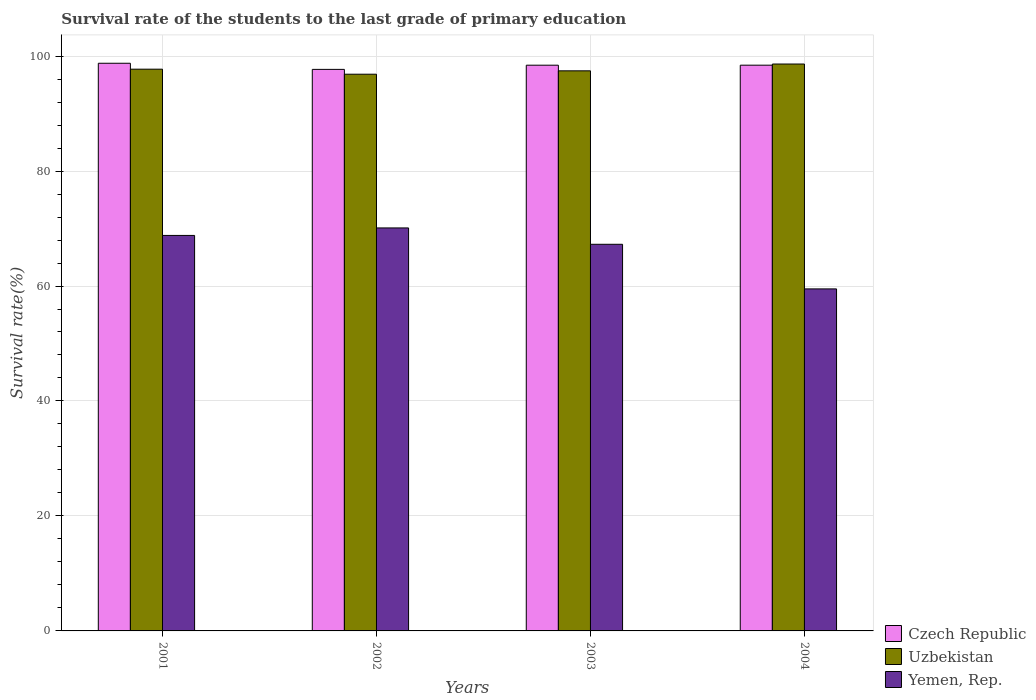Are the number of bars on each tick of the X-axis equal?
Give a very brief answer. Yes. How many bars are there on the 2nd tick from the left?
Ensure brevity in your answer.  3. What is the label of the 1st group of bars from the left?
Ensure brevity in your answer.  2001. In how many cases, is the number of bars for a given year not equal to the number of legend labels?
Provide a short and direct response. 0. What is the survival rate of the students in Yemen, Rep. in 2001?
Provide a succinct answer. 68.8. Across all years, what is the maximum survival rate of the students in Czech Republic?
Give a very brief answer. 98.75. Across all years, what is the minimum survival rate of the students in Uzbekistan?
Your answer should be compact. 96.84. In which year was the survival rate of the students in Yemen, Rep. maximum?
Give a very brief answer. 2002. In which year was the survival rate of the students in Uzbekistan minimum?
Offer a very short reply. 2002. What is the total survival rate of the students in Uzbekistan in the graph?
Offer a very short reply. 390.61. What is the difference between the survival rate of the students in Czech Republic in 2002 and that in 2004?
Make the answer very short. -0.73. What is the difference between the survival rate of the students in Czech Republic in 2003 and the survival rate of the students in Uzbekistan in 2001?
Your response must be concise. 0.69. What is the average survival rate of the students in Yemen, Rep. per year?
Provide a succinct answer. 66.41. In the year 2002, what is the difference between the survival rate of the students in Uzbekistan and survival rate of the students in Czech Republic?
Offer a very short reply. -0.84. What is the ratio of the survival rate of the students in Yemen, Rep. in 2001 to that in 2003?
Your answer should be very brief. 1.02. Is the difference between the survival rate of the students in Uzbekistan in 2001 and 2004 greater than the difference between the survival rate of the students in Czech Republic in 2001 and 2004?
Ensure brevity in your answer.  No. What is the difference between the highest and the second highest survival rate of the students in Yemen, Rep.?
Provide a short and direct response. 1.31. What is the difference between the highest and the lowest survival rate of the students in Uzbekistan?
Your answer should be very brief. 1.77. Is the sum of the survival rate of the students in Uzbekistan in 2001 and 2004 greater than the maximum survival rate of the students in Yemen, Rep. across all years?
Your answer should be compact. Yes. What does the 1st bar from the left in 2004 represents?
Provide a short and direct response. Czech Republic. What does the 1st bar from the right in 2001 represents?
Your response must be concise. Yemen, Rep. Is it the case that in every year, the sum of the survival rate of the students in Yemen, Rep. and survival rate of the students in Uzbekistan is greater than the survival rate of the students in Czech Republic?
Keep it short and to the point. Yes. How many bars are there?
Your response must be concise. 12. How many years are there in the graph?
Your answer should be compact. 4. What is the difference between two consecutive major ticks on the Y-axis?
Ensure brevity in your answer.  20. Are the values on the major ticks of Y-axis written in scientific E-notation?
Provide a succinct answer. No. Does the graph contain grids?
Give a very brief answer. Yes. Where does the legend appear in the graph?
Your response must be concise. Bottom right. How many legend labels are there?
Ensure brevity in your answer.  3. What is the title of the graph?
Ensure brevity in your answer.  Survival rate of the students to the last grade of primary education. What is the label or title of the X-axis?
Provide a short and direct response. Years. What is the label or title of the Y-axis?
Your answer should be very brief. Survival rate(%). What is the Survival rate(%) in Czech Republic in 2001?
Your answer should be very brief. 98.75. What is the Survival rate(%) in Uzbekistan in 2001?
Your response must be concise. 97.72. What is the Survival rate(%) in Yemen, Rep. in 2001?
Your response must be concise. 68.8. What is the Survival rate(%) in Czech Republic in 2002?
Give a very brief answer. 97.68. What is the Survival rate(%) in Uzbekistan in 2002?
Ensure brevity in your answer.  96.84. What is the Survival rate(%) in Yemen, Rep. in 2002?
Your answer should be very brief. 70.1. What is the Survival rate(%) in Czech Republic in 2003?
Give a very brief answer. 98.41. What is the Survival rate(%) in Uzbekistan in 2003?
Provide a short and direct response. 97.43. What is the Survival rate(%) in Yemen, Rep. in 2003?
Your answer should be compact. 67.26. What is the Survival rate(%) in Czech Republic in 2004?
Provide a succinct answer. 98.42. What is the Survival rate(%) in Uzbekistan in 2004?
Ensure brevity in your answer.  98.62. What is the Survival rate(%) of Yemen, Rep. in 2004?
Your answer should be compact. 59.5. Across all years, what is the maximum Survival rate(%) in Czech Republic?
Give a very brief answer. 98.75. Across all years, what is the maximum Survival rate(%) of Uzbekistan?
Keep it short and to the point. 98.62. Across all years, what is the maximum Survival rate(%) of Yemen, Rep.?
Offer a very short reply. 70.1. Across all years, what is the minimum Survival rate(%) of Czech Republic?
Give a very brief answer. 97.68. Across all years, what is the minimum Survival rate(%) in Uzbekistan?
Provide a succinct answer. 96.84. Across all years, what is the minimum Survival rate(%) of Yemen, Rep.?
Offer a very short reply. 59.5. What is the total Survival rate(%) of Czech Republic in the graph?
Provide a short and direct response. 393.26. What is the total Survival rate(%) in Uzbekistan in the graph?
Make the answer very short. 390.61. What is the total Survival rate(%) in Yemen, Rep. in the graph?
Give a very brief answer. 265.65. What is the difference between the Survival rate(%) in Czech Republic in 2001 and that in 2002?
Your response must be concise. 1.06. What is the difference between the Survival rate(%) in Uzbekistan in 2001 and that in 2002?
Ensure brevity in your answer.  0.88. What is the difference between the Survival rate(%) in Yemen, Rep. in 2001 and that in 2002?
Ensure brevity in your answer.  -1.31. What is the difference between the Survival rate(%) in Czech Republic in 2001 and that in 2003?
Give a very brief answer. 0.34. What is the difference between the Survival rate(%) in Uzbekistan in 2001 and that in 2003?
Provide a succinct answer. 0.29. What is the difference between the Survival rate(%) in Yemen, Rep. in 2001 and that in 2003?
Offer a very short reply. 1.54. What is the difference between the Survival rate(%) of Czech Republic in 2001 and that in 2004?
Offer a terse response. 0.33. What is the difference between the Survival rate(%) of Uzbekistan in 2001 and that in 2004?
Offer a terse response. -0.9. What is the difference between the Survival rate(%) of Yemen, Rep. in 2001 and that in 2004?
Provide a short and direct response. 9.3. What is the difference between the Survival rate(%) in Czech Republic in 2002 and that in 2003?
Your answer should be very brief. -0.73. What is the difference between the Survival rate(%) of Uzbekistan in 2002 and that in 2003?
Your response must be concise. -0.59. What is the difference between the Survival rate(%) of Yemen, Rep. in 2002 and that in 2003?
Offer a very short reply. 2.85. What is the difference between the Survival rate(%) in Czech Republic in 2002 and that in 2004?
Your answer should be very brief. -0.73. What is the difference between the Survival rate(%) of Uzbekistan in 2002 and that in 2004?
Your response must be concise. -1.77. What is the difference between the Survival rate(%) of Yemen, Rep. in 2002 and that in 2004?
Your answer should be very brief. 10.61. What is the difference between the Survival rate(%) in Czech Republic in 2003 and that in 2004?
Ensure brevity in your answer.  -0. What is the difference between the Survival rate(%) in Uzbekistan in 2003 and that in 2004?
Your answer should be very brief. -1.18. What is the difference between the Survival rate(%) in Yemen, Rep. in 2003 and that in 2004?
Offer a terse response. 7.76. What is the difference between the Survival rate(%) of Czech Republic in 2001 and the Survival rate(%) of Uzbekistan in 2002?
Offer a terse response. 1.91. What is the difference between the Survival rate(%) of Czech Republic in 2001 and the Survival rate(%) of Yemen, Rep. in 2002?
Offer a very short reply. 28.65. What is the difference between the Survival rate(%) in Uzbekistan in 2001 and the Survival rate(%) in Yemen, Rep. in 2002?
Your answer should be compact. 27.62. What is the difference between the Survival rate(%) in Czech Republic in 2001 and the Survival rate(%) in Uzbekistan in 2003?
Keep it short and to the point. 1.32. What is the difference between the Survival rate(%) of Czech Republic in 2001 and the Survival rate(%) of Yemen, Rep. in 2003?
Provide a succinct answer. 31.49. What is the difference between the Survival rate(%) of Uzbekistan in 2001 and the Survival rate(%) of Yemen, Rep. in 2003?
Your answer should be very brief. 30.46. What is the difference between the Survival rate(%) of Czech Republic in 2001 and the Survival rate(%) of Uzbekistan in 2004?
Your answer should be very brief. 0.13. What is the difference between the Survival rate(%) in Czech Republic in 2001 and the Survival rate(%) in Yemen, Rep. in 2004?
Offer a very short reply. 39.25. What is the difference between the Survival rate(%) of Uzbekistan in 2001 and the Survival rate(%) of Yemen, Rep. in 2004?
Offer a very short reply. 38.22. What is the difference between the Survival rate(%) of Czech Republic in 2002 and the Survival rate(%) of Uzbekistan in 2003?
Provide a succinct answer. 0.25. What is the difference between the Survival rate(%) in Czech Republic in 2002 and the Survival rate(%) in Yemen, Rep. in 2003?
Give a very brief answer. 30.43. What is the difference between the Survival rate(%) of Uzbekistan in 2002 and the Survival rate(%) of Yemen, Rep. in 2003?
Your response must be concise. 29.59. What is the difference between the Survival rate(%) in Czech Republic in 2002 and the Survival rate(%) in Uzbekistan in 2004?
Ensure brevity in your answer.  -0.93. What is the difference between the Survival rate(%) of Czech Republic in 2002 and the Survival rate(%) of Yemen, Rep. in 2004?
Keep it short and to the point. 38.19. What is the difference between the Survival rate(%) in Uzbekistan in 2002 and the Survival rate(%) in Yemen, Rep. in 2004?
Your answer should be very brief. 37.35. What is the difference between the Survival rate(%) of Czech Republic in 2003 and the Survival rate(%) of Uzbekistan in 2004?
Provide a succinct answer. -0.2. What is the difference between the Survival rate(%) of Czech Republic in 2003 and the Survival rate(%) of Yemen, Rep. in 2004?
Ensure brevity in your answer.  38.91. What is the difference between the Survival rate(%) of Uzbekistan in 2003 and the Survival rate(%) of Yemen, Rep. in 2004?
Your response must be concise. 37.93. What is the average Survival rate(%) in Czech Republic per year?
Your answer should be compact. 98.32. What is the average Survival rate(%) of Uzbekistan per year?
Give a very brief answer. 97.65. What is the average Survival rate(%) in Yemen, Rep. per year?
Give a very brief answer. 66.41. In the year 2001, what is the difference between the Survival rate(%) of Czech Republic and Survival rate(%) of Uzbekistan?
Provide a succinct answer. 1.03. In the year 2001, what is the difference between the Survival rate(%) in Czech Republic and Survival rate(%) in Yemen, Rep.?
Provide a succinct answer. 29.95. In the year 2001, what is the difference between the Survival rate(%) of Uzbekistan and Survival rate(%) of Yemen, Rep.?
Ensure brevity in your answer.  28.92. In the year 2002, what is the difference between the Survival rate(%) in Czech Republic and Survival rate(%) in Uzbekistan?
Provide a short and direct response. 0.84. In the year 2002, what is the difference between the Survival rate(%) of Czech Republic and Survival rate(%) of Yemen, Rep.?
Give a very brief answer. 27.58. In the year 2002, what is the difference between the Survival rate(%) in Uzbekistan and Survival rate(%) in Yemen, Rep.?
Provide a short and direct response. 26.74. In the year 2003, what is the difference between the Survival rate(%) of Czech Republic and Survival rate(%) of Uzbekistan?
Provide a short and direct response. 0.98. In the year 2003, what is the difference between the Survival rate(%) of Czech Republic and Survival rate(%) of Yemen, Rep.?
Provide a short and direct response. 31.16. In the year 2003, what is the difference between the Survival rate(%) of Uzbekistan and Survival rate(%) of Yemen, Rep.?
Offer a very short reply. 30.18. In the year 2004, what is the difference between the Survival rate(%) in Czech Republic and Survival rate(%) in Uzbekistan?
Make the answer very short. -0.2. In the year 2004, what is the difference between the Survival rate(%) in Czech Republic and Survival rate(%) in Yemen, Rep.?
Provide a succinct answer. 38.92. In the year 2004, what is the difference between the Survival rate(%) in Uzbekistan and Survival rate(%) in Yemen, Rep.?
Offer a very short reply. 39.12. What is the ratio of the Survival rate(%) in Czech Republic in 2001 to that in 2002?
Your answer should be compact. 1.01. What is the ratio of the Survival rate(%) in Yemen, Rep. in 2001 to that in 2002?
Make the answer very short. 0.98. What is the ratio of the Survival rate(%) in Czech Republic in 2001 to that in 2003?
Make the answer very short. 1. What is the ratio of the Survival rate(%) in Uzbekistan in 2001 to that in 2003?
Offer a terse response. 1. What is the ratio of the Survival rate(%) of Yemen, Rep. in 2001 to that in 2003?
Your answer should be very brief. 1.02. What is the ratio of the Survival rate(%) in Czech Republic in 2001 to that in 2004?
Your response must be concise. 1. What is the ratio of the Survival rate(%) of Uzbekistan in 2001 to that in 2004?
Ensure brevity in your answer.  0.99. What is the ratio of the Survival rate(%) of Yemen, Rep. in 2001 to that in 2004?
Make the answer very short. 1.16. What is the ratio of the Survival rate(%) in Czech Republic in 2002 to that in 2003?
Ensure brevity in your answer.  0.99. What is the ratio of the Survival rate(%) in Uzbekistan in 2002 to that in 2003?
Your answer should be very brief. 0.99. What is the ratio of the Survival rate(%) of Yemen, Rep. in 2002 to that in 2003?
Offer a terse response. 1.04. What is the ratio of the Survival rate(%) in Czech Republic in 2002 to that in 2004?
Offer a terse response. 0.99. What is the ratio of the Survival rate(%) in Yemen, Rep. in 2002 to that in 2004?
Provide a short and direct response. 1.18. What is the ratio of the Survival rate(%) in Yemen, Rep. in 2003 to that in 2004?
Your answer should be compact. 1.13. What is the difference between the highest and the second highest Survival rate(%) in Czech Republic?
Your answer should be compact. 0.33. What is the difference between the highest and the second highest Survival rate(%) of Uzbekistan?
Your response must be concise. 0.9. What is the difference between the highest and the second highest Survival rate(%) in Yemen, Rep.?
Give a very brief answer. 1.31. What is the difference between the highest and the lowest Survival rate(%) in Czech Republic?
Offer a very short reply. 1.06. What is the difference between the highest and the lowest Survival rate(%) of Uzbekistan?
Provide a succinct answer. 1.77. What is the difference between the highest and the lowest Survival rate(%) of Yemen, Rep.?
Your response must be concise. 10.61. 